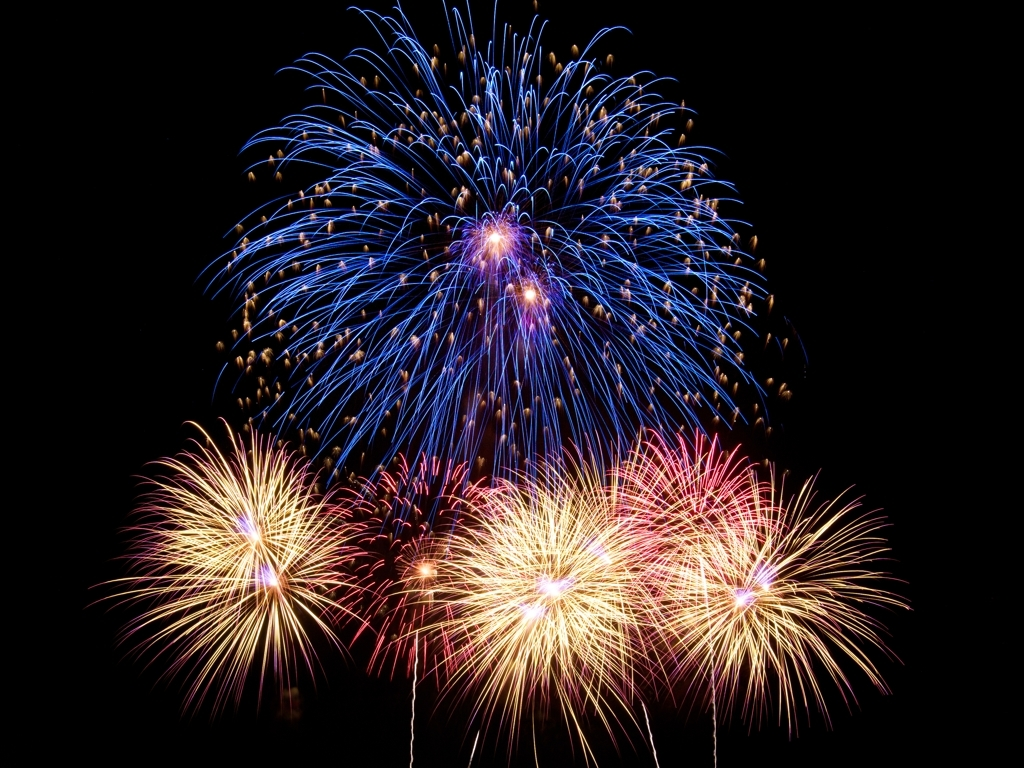What event might these fireworks be celebrating? These fireworks could be part of a celebration for a national holiday, major festival, or a large public event such as New Year's Eve, Independence Day, or an international sports competition. 